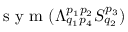Convert formula to latex. <formula><loc_0><loc_0><loc_500><loc_500>s y m ( \Lambda _ { q _ { 1 } p _ { 4 } } ^ { p _ { 1 } p _ { 2 } } S _ { q _ { 2 } } ^ { p _ { 3 } } )</formula> 